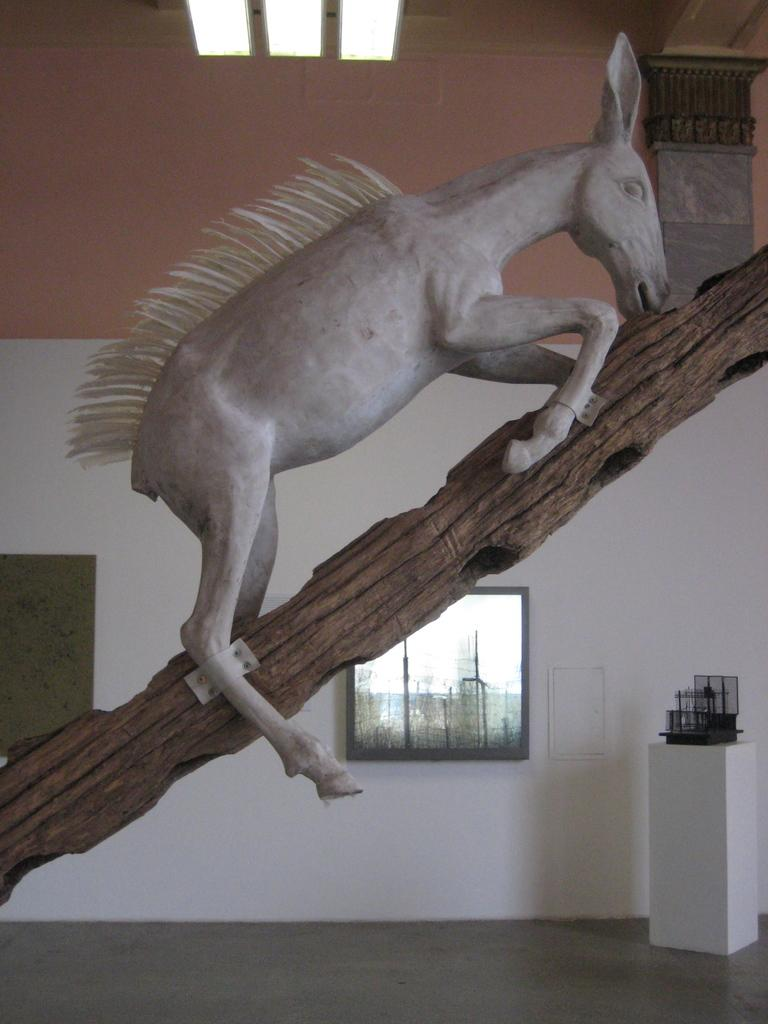What animal is depicted in the image? There is a depiction of a horse in the image. Where is the horse located in the image? The horse is on a branch in the image. What can be seen in the background of the image? There is a wall in the background of the image. What organization is responsible for the horse's arm in the image? There is no horse's arm present in the image, and no organization is mentioned or implied. 